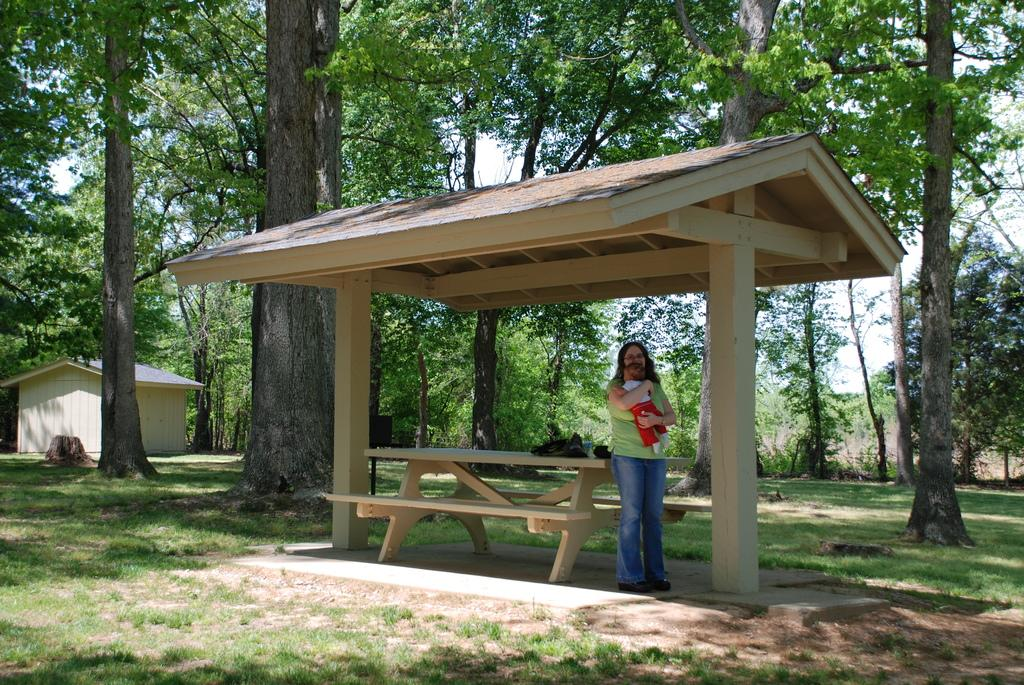Who is the main subject in the image? There is a woman standing in the center of the image. What is the woman doing in the image? The woman is holding a kid. What can be seen in the background of the image? There is sky, trees, grass, sheds, and a few other objects visible in the background of the image. What type of pets can be seen in the advertisement in the image? There is no advertisement present in the image, and therefore no pets can be seen. 